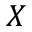Convert formula to latex. <formula><loc_0><loc_0><loc_500><loc_500>X</formula> 